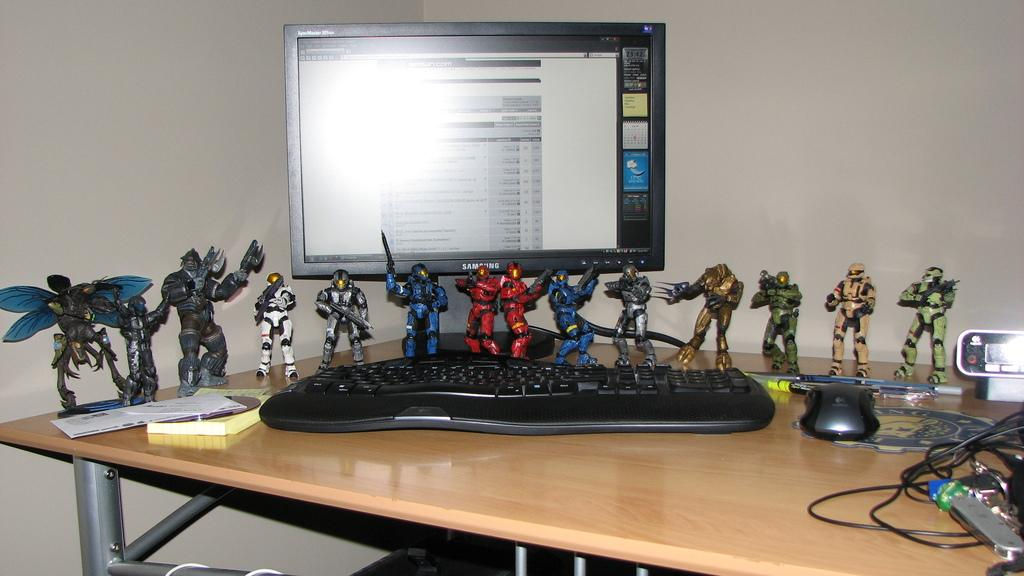What is placed on the table in the image? There is a book, a card, toys, cables, a mouse, a keyboard, and a monitor on the table. What type of items are present on the table that are related to technology? There is a mouse, a keyboard, and a monitor on the table, which are related to technology. What is the color of the wall in the image? The wall is white in color. What type of quince is being served in the image? There is no quince present in the image; it features a table with various objects, including a book, a card, toys, cables, a mouse, a keyboard, and a monitor. 